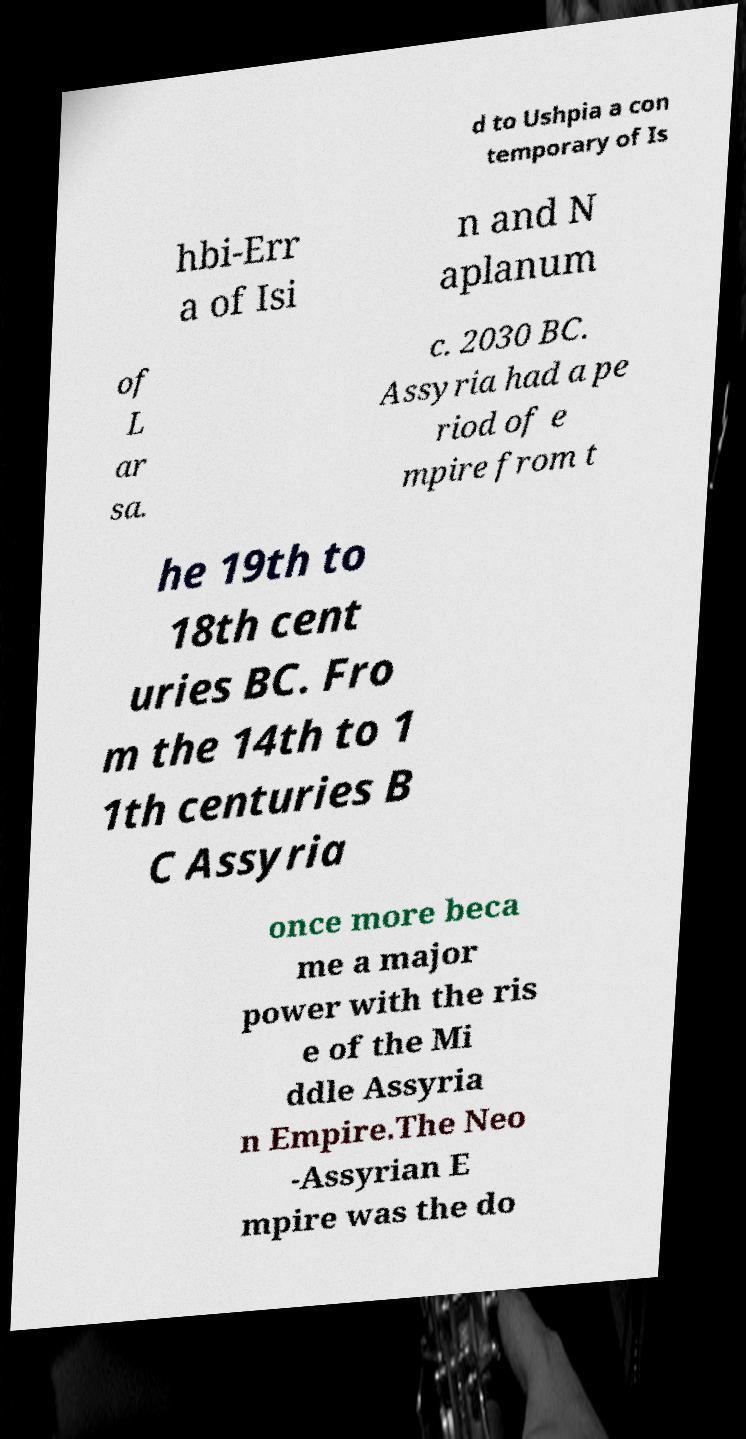Please read and relay the text visible in this image. What does it say? d to Ushpia a con temporary of Is hbi-Err a of Isi n and N aplanum of L ar sa. c. 2030 BC. Assyria had a pe riod of e mpire from t he 19th to 18th cent uries BC. Fro m the 14th to 1 1th centuries B C Assyria once more beca me a major power with the ris e of the Mi ddle Assyria n Empire.The Neo -Assyrian E mpire was the do 